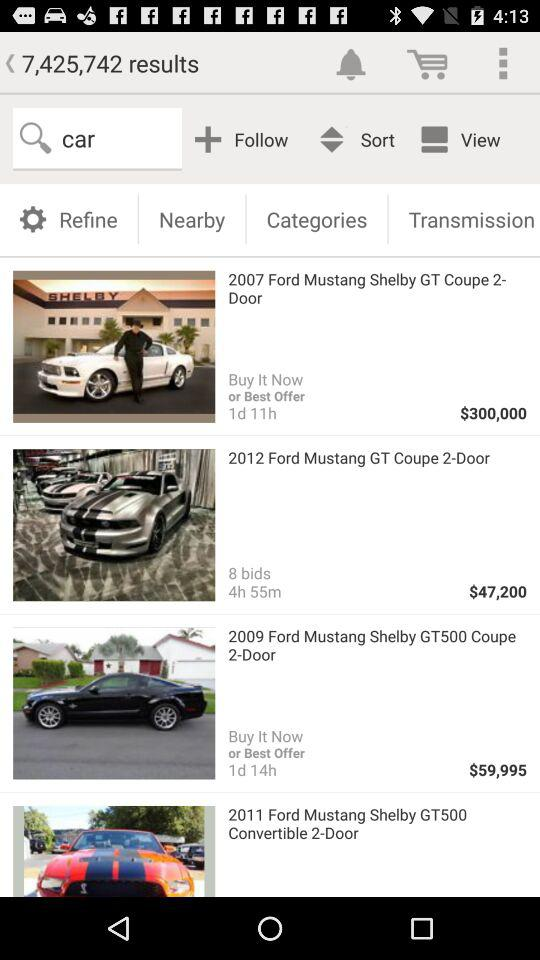What is the name of the car that costs $59,995? The name of the car is "2009 Ford Mustang Shelby GT500 Coupe 2-Door". 